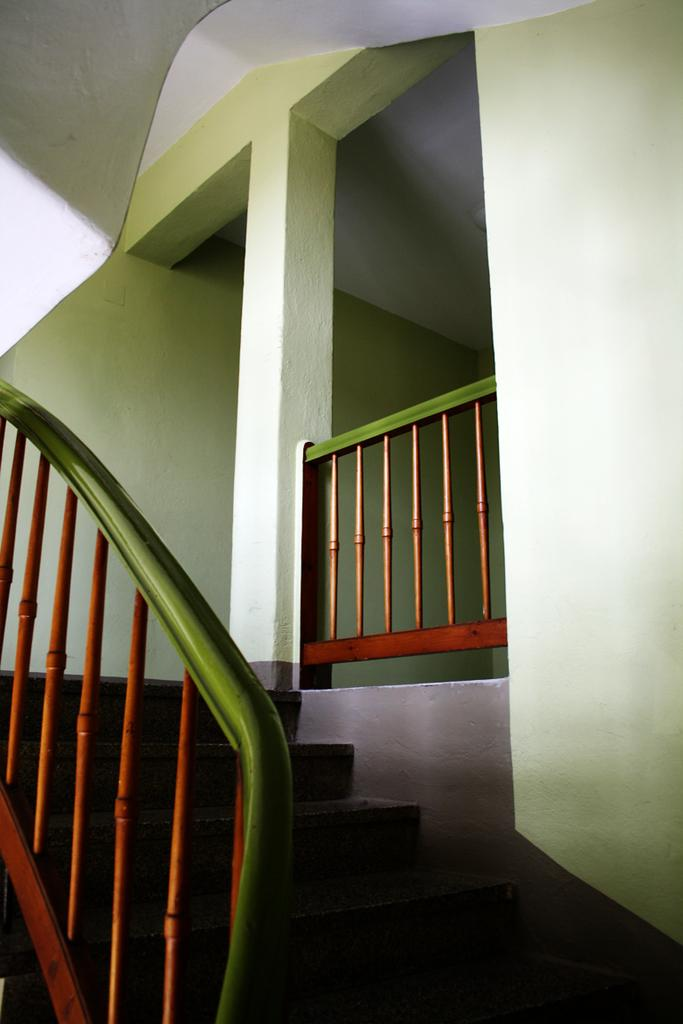Where was the image most likely taken? The image was likely taken inside a house. What can be seen on the stairs in the image? There is a staircase holder on the stairs in the image. What architectural feature is present in the image? There is a pillar in the image. What is the color of the wall in the image? The wall is light green in color. Can you see an uncle riding a train in the image? There is no uncle or train present in the image. What type of bean is growing on the wall in the image? There are no beans growing on the wall in the image; it is a light green wall. 